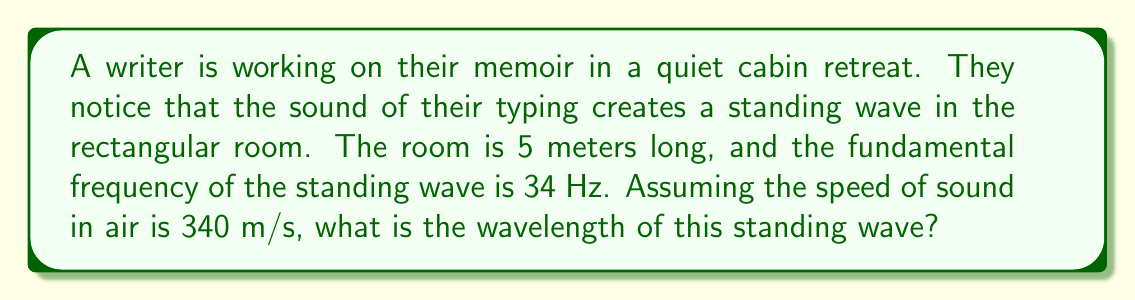Can you solve this math problem? To solve this problem, we'll follow these steps:

1) First, recall the relationship between wavelength ($\lambda$), frequency ($f$), and wave speed ($v$):

   $$v = f\lambda$$

2) We're given that the speed of sound $v = 340$ m/s and the frequency $f = 34$ Hz.

3) We can rearrange the equation to solve for wavelength:

   $$\lambda = \frac{v}{f}$$

4) Substituting our known values:

   $$\lambda = \frac{340 \text{ m/s}}{34 \text{ Hz}} = 10 \text{ m}$$

5) Now, let's consider why this is the fundamental frequency. In a standing wave, the length of the room ($L$) must be equal to half of the wavelength for the fundamental frequency:

   $$L = \frac{\lambda}{2}$$

6) We can verify this with our given room length of 5 meters:

   $$5 \text{ m} = \frac{10 \text{ m}}{2}$$

This confirms that our calculated wavelength is correct and consistent with the given information about the room and the fundamental frequency.
Answer: $\lambda = 10 \text{ m}$ 